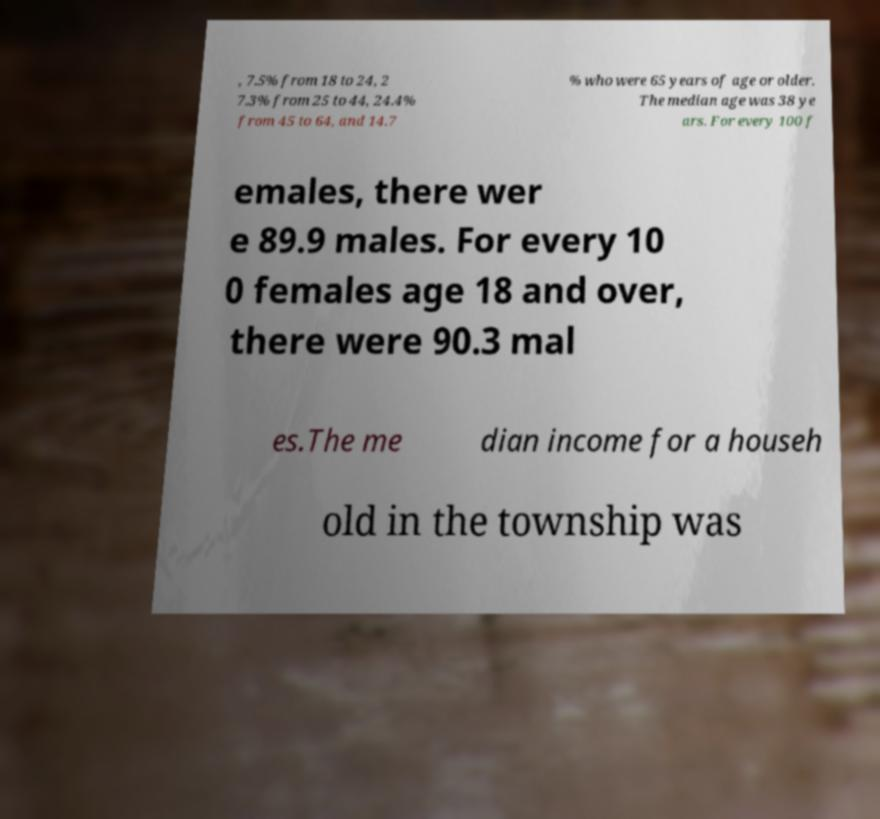For documentation purposes, I need the text within this image transcribed. Could you provide that? , 7.5% from 18 to 24, 2 7.3% from 25 to 44, 24.4% from 45 to 64, and 14.7 % who were 65 years of age or older. The median age was 38 ye ars. For every 100 f emales, there wer e 89.9 males. For every 10 0 females age 18 and over, there were 90.3 mal es.The me dian income for a househ old in the township was 